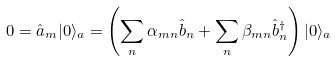<formula> <loc_0><loc_0><loc_500><loc_500>0 = \hat { a } _ { m } | 0 \rangle _ { a } = \left ( \sum _ { n } \alpha _ { m n } \hat { b } _ { n } + \sum _ { n } \beta _ { m n } \hat { b } ^ { \dagger } _ { n } \right ) | 0 \rangle _ { a }</formula> 